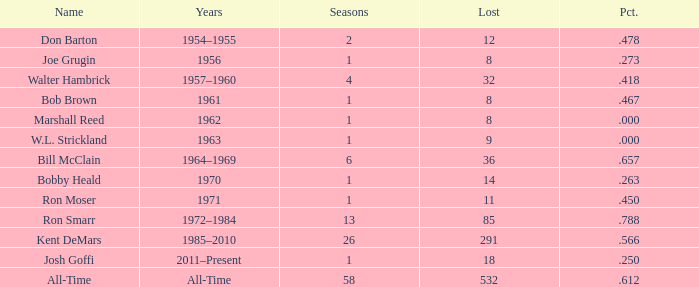In what seasons is joe grugin's name present and has a lost exceeding 8? 0.0. 